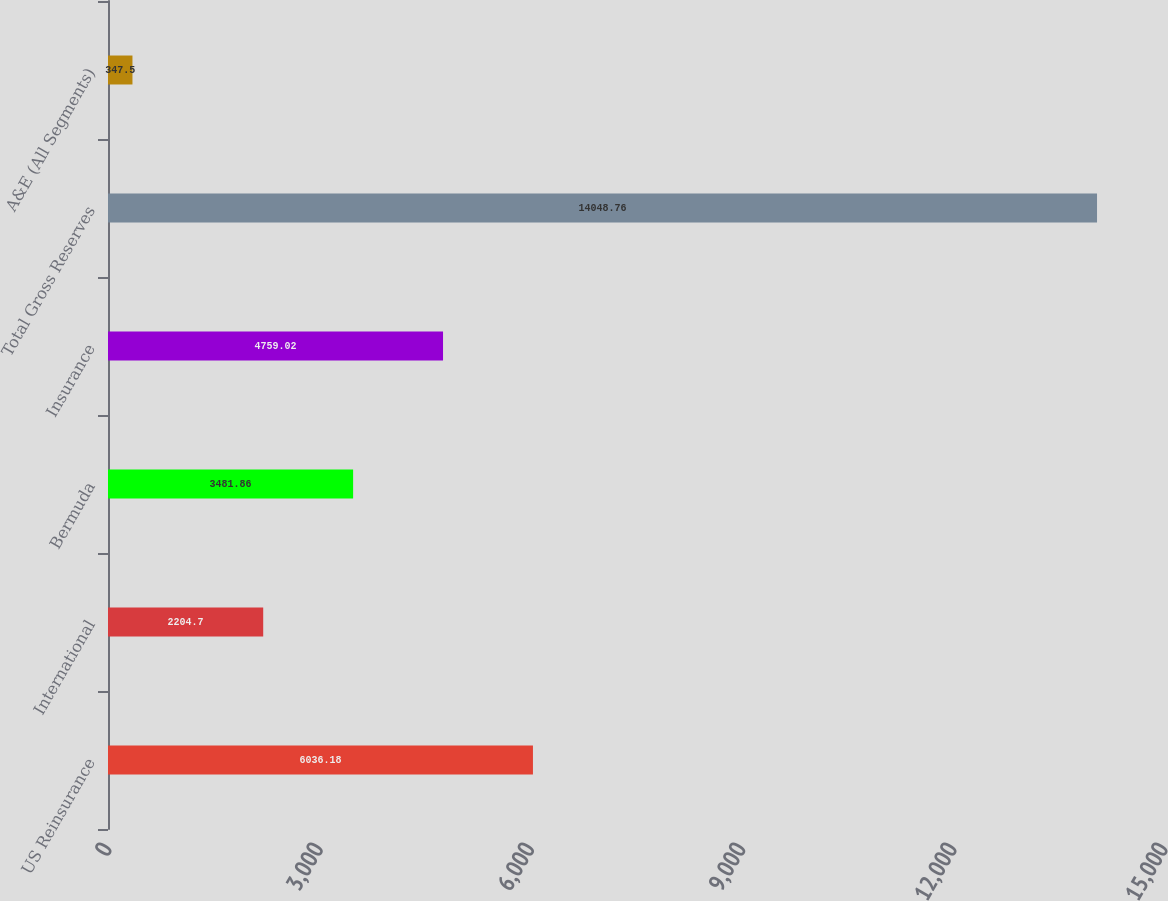<chart> <loc_0><loc_0><loc_500><loc_500><bar_chart><fcel>US Reinsurance<fcel>International<fcel>Bermuda<fcel>Insurance<fcel>Total Gross Reserves<fcel>A&E (All Segments)<nl><fcel>6036.18<fcel>2204.7<fcel>3481.86<fcel>4759.02<fcel>14048.8<fcel>347.5<nl></chart> 